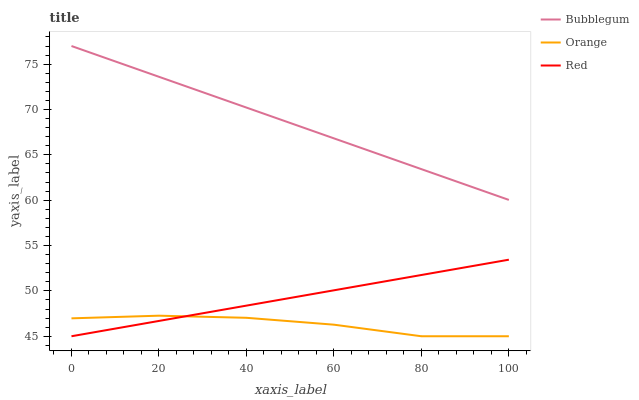Does Orange have the minimum area under the curve?
Answer yes or no. Yes. Does Bubblegum have the maximum area under the curve?
Answer yes or no. Yes. Does Red have the minimum area under the curve?
Answer yes or no. No. Does Red have the maximum area under the curve?
Answer yes or no. No. Is Red the smoothest?
Answer yes or no. Yes. Is Orange the roughest?
Answer yes or no. Yes. Is Bubblegum the smoothest?
Answer yes or no. No. Is Bubblegum the roughest?
Answer yes or no. No. Does Orange have the lowest value?
Answer yes or no. Yes. Does Bubblegum have the lowest value?
Answer yes or no. No. Does Bubblegum have the highest value?
Answer yes or no. Yes. Does Red have the highest value?
Answer yes or no. No. Is Red less than Bubblegum?
Answer yes or no. Yes. Is Bubblegum greater than Orange?
Answer yes or no. Yes. Does Orange intersect Red?
Answer yes or no. Yes. Is Orange less than Red?
Answer yes or no. No. Is Orange greater than Red?
Answer yes or no. No. Does Red intersect Bubblegum?
Answer yes or no. No. 